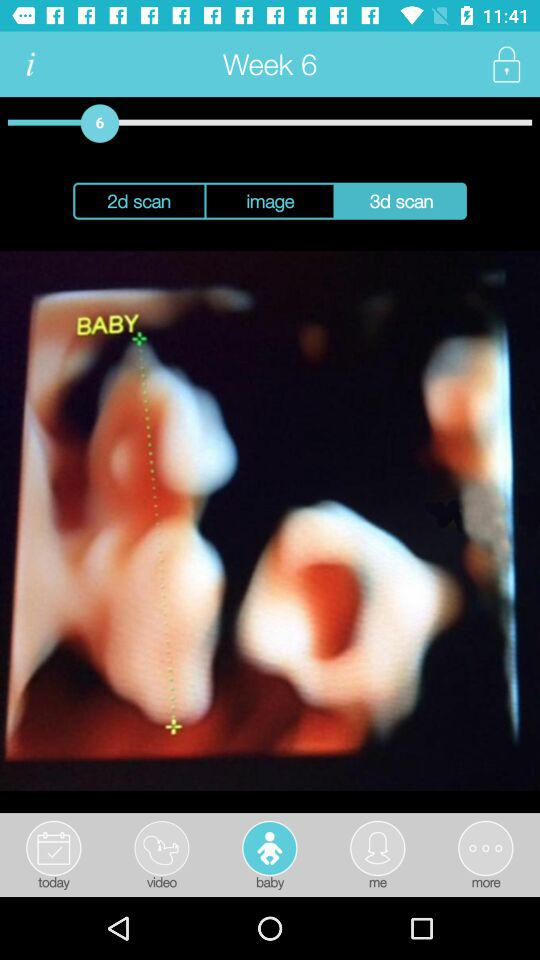Which tab has been selected? The selected tab is "baby". 